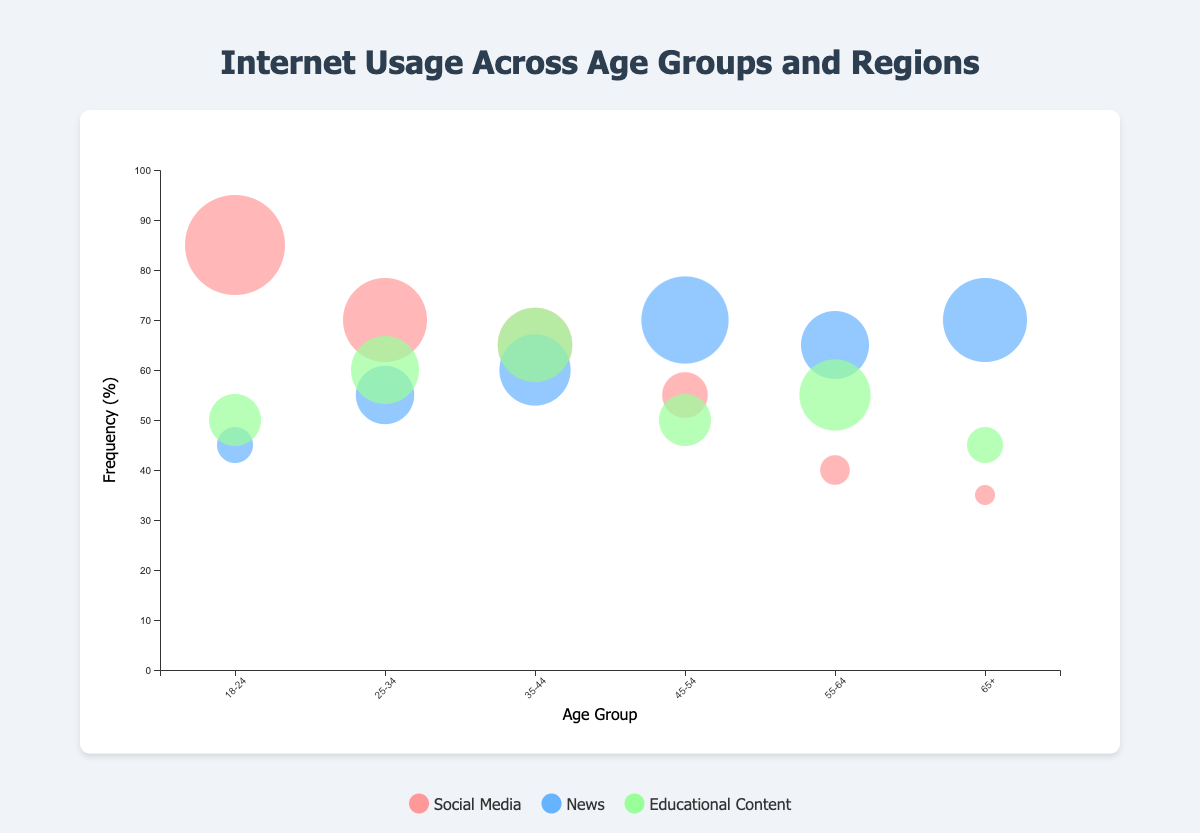What is the overall trend in the frequency of social media usage across age groups? The frequency of social media usage tends to decrease with increasing age. Younger age groups like 18-24 (85%) and 25-34 (70%) have higher frequencies compared to older age groups like 55-64 (40%) and 65+ (35%).
Answer: Social media usage decreases with age Which region has the highest frequency of educational content usage among all age groups? By examining the vertical positions of the bubbles for educational content across all age groups, we find that the highest frequency is in the age group 35-44 for Asia, with a frequency of 65%.
Answer: Asia (35-44 age group) How does the frequency of news consumption for the age group 45-54 in South America compare to the same age group’s social media usage? For the age group 45-54 in South America, the frequency of news consumption is 70%, while the frequency of social media usage is 55%. Comparing these, news consumption is higher by 15%.
Answer: News consumption is higher by 15% What is the median frequency of educational content usage across all age groups? The frequencies of educational content usage for each age group are: 50%, 60%, 65%, 50%, 55%, 45%. Arranging them in ascending order (45, 50, 50, 55, 60, 65), the median is the average of the 3rd and 4th values: (50+55)/2 = 52.5%.
Answer: 52.5% In which age group and region is social media usage the lowest? To find the lowest social media usage, we look at the vertical positions of the social media bubbles across all age groups and regions. The lowest frequency is 35% for the age group 65+ in Australia.
Answer: Age group 65+ in Australia Which activity type has the most consistent usage frequency across all age groups? By visual assessment, the bubbles for news are closer in vertical position across multiple age groups, indicating more consistent usage frequency compared to social media and educational content.
Answer: News How does the social media usage frequency in North America for the 18-24 age group compare to Europe for the 25-34 age group? The social media usage frequency for the 18-24 age group in North America is 85%, while for the 25-34 age group in Europe it is 70%. The difference between them is 85 - 70 = 15%.
Answer: 85% in North America (18-24) is higher by 15% How many regions show a higher frequency of educational content usage than social media for the 55-64 age group? For the 55-64 age group in Africa: educational content (55%) and social media (40%). Comparing these, educational content usage is higher than social media. Thus, there is 1 region where this is true.
Answer: 1 region (Africa) Which activity and age group show the largest bubble size and what is its value? The largest bubble size can be identified visually. It is the "Social Media" activity for the 18-24 age group in North America, with a relative size of 40.
Answer: Social Media, 18-24 age group (North America), size 40 What is the average frequency of social media usage across all regions for the age group 35-44? The frequencies of social media usage for the age group 35-44 in Asia are 65%. There is only one value, so the average is just 65%.
Answer: 65% 